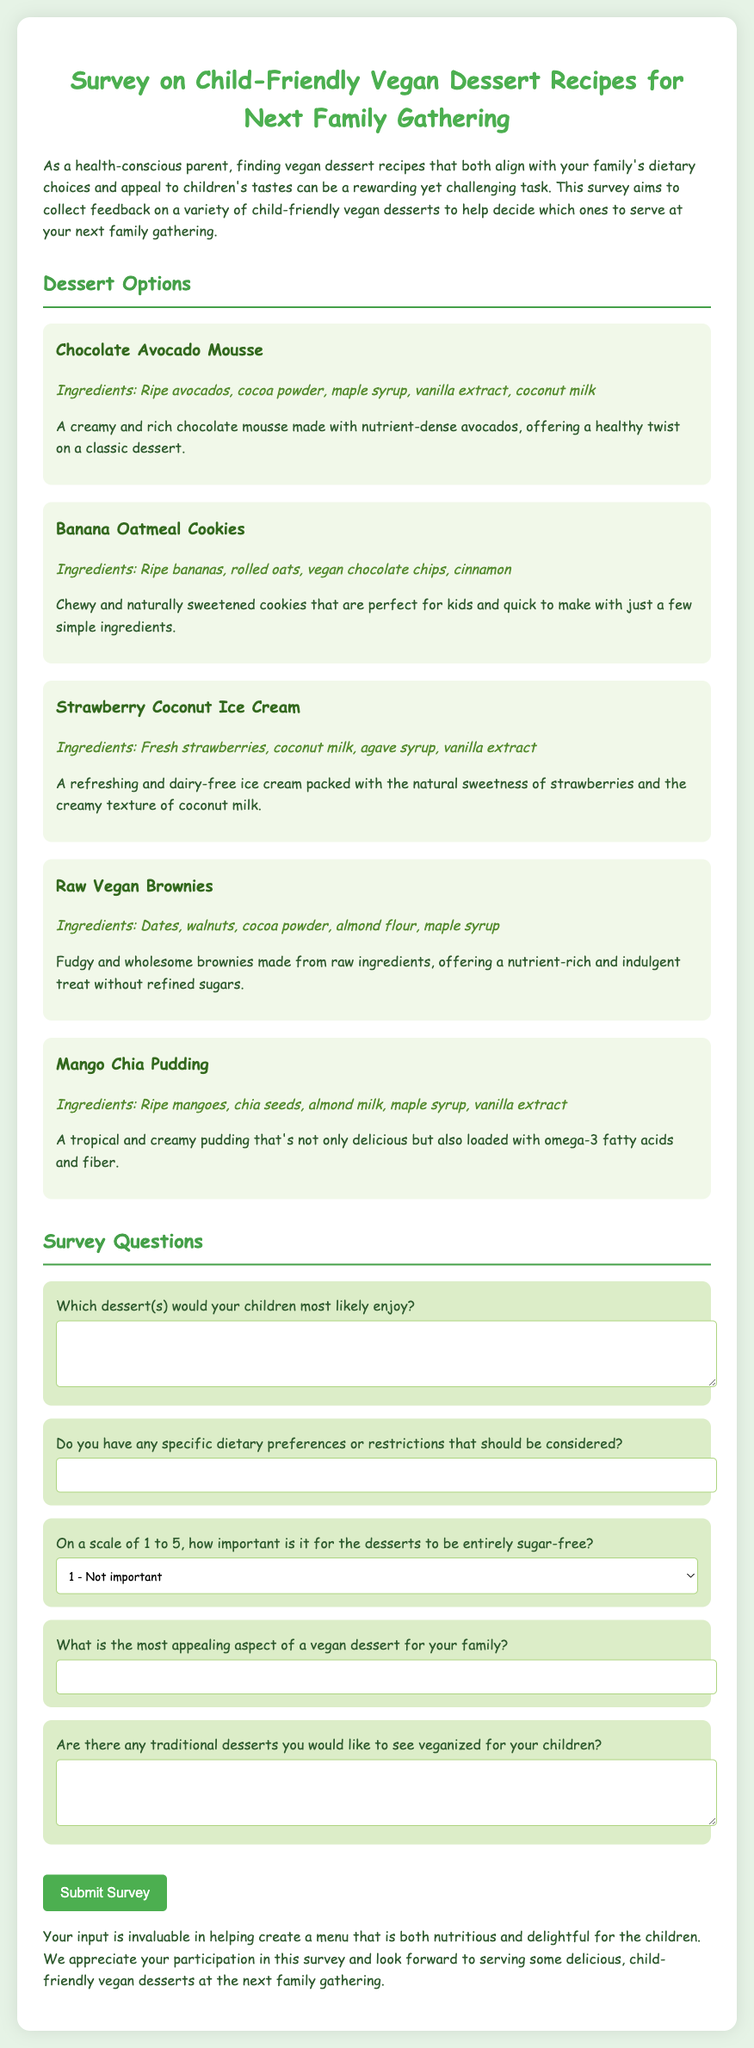What is the title of the survey? The title of the survey is stated at the beginning of the document as "Survey on Child-Friendly Vegan Dessert Recipes for Next Family Gathering."
Answer: Survey on Child-Friendly Vegan Dessert Recipes for Next Family Gathering What is one ingredient in the Chocolate Avocado Mousse? The document lists the ingredients for each dessert; for the Chocolate Avocado Mousse, one ingredient is ripe avocados.
Answer: Ripe avocados What dessert option contains rolled oats? The Banana Oatmeal Cookies are mentioned in the dessert options and they contain rolled oats.
Answer: Banana Oatmeal Cookies On a scale of 1 to 5, what is the highest importance level for the desserts to be entirely sugar-free? The highest importance level on the scale provided in the document is 5.
Answer: 5 What is the most appealing aspect of a vegan dessert for your family? This question allows for personal interpretation; it asks for an open-ended response in the space provided next to it.
Answer: Open-ended response What dietary restrictions may be included in the survey? The survey includes an open question asking for any specific dietary preferences or restrictions such as gluten-free or nut-free.
Answer: Open-ended response What dessert is made from raw ingredients? The Raw Vegan Brownies are explicitly mentioned as being made from raw ingredients.
Answer: Raw Vegan Brownies Which dessert features strawberries as a main ingredient? The Strawberry Coconut Ice Cream is the dessert option that features fresh strawberries.
Answer: Strawberry Coconut Ice Cream What category does this document belong to? This document represents a survey related to food preferences, specifically vegan desserts suitable for children.
Answer: Survey on vegan desserts 